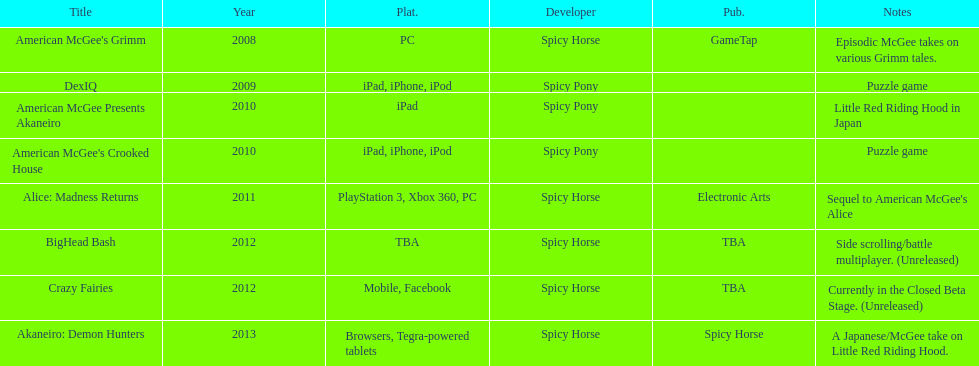What are the number of times an ipad was used as a platform? 3. 